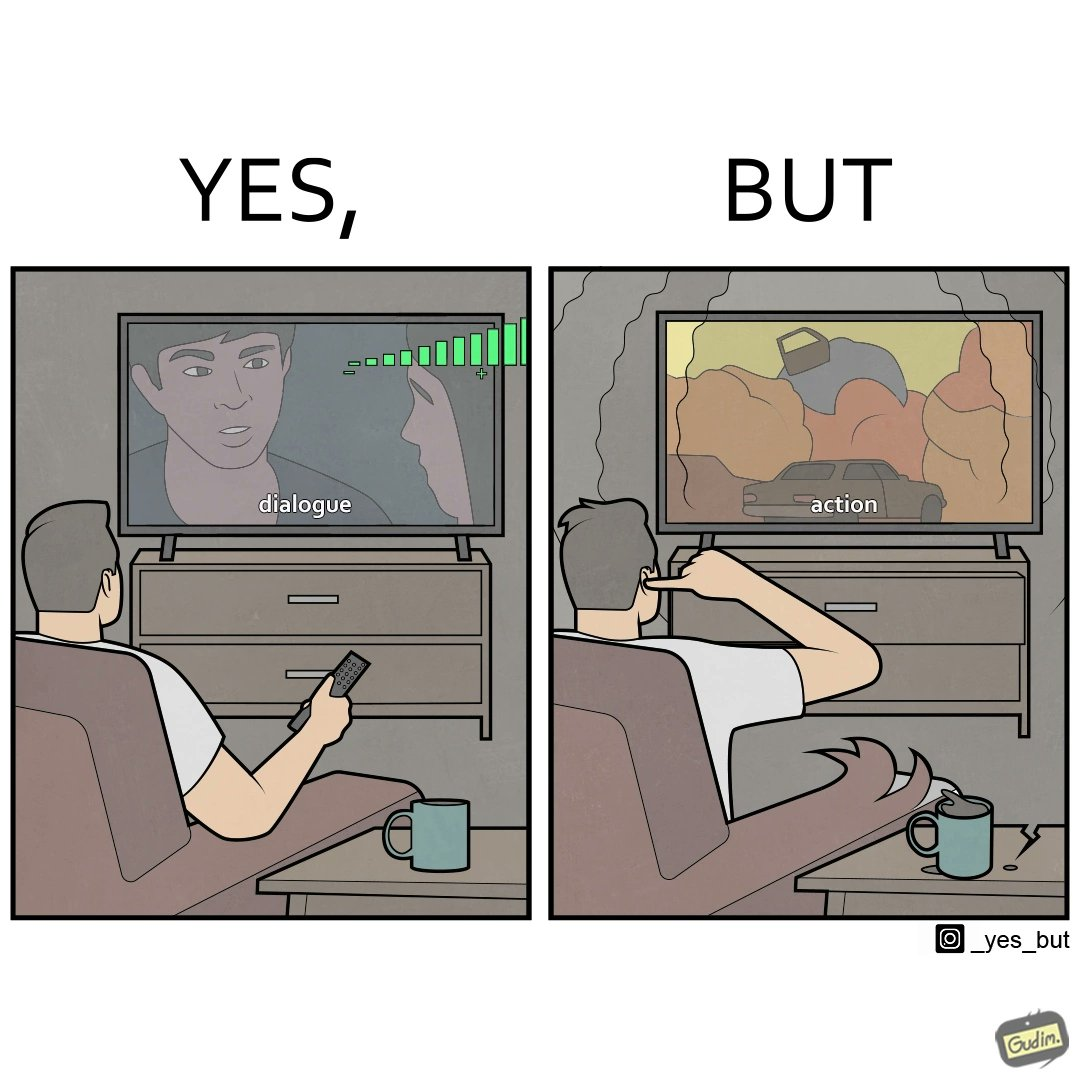Is this image satirical or non-satirical? Yes, this image is satirical. 